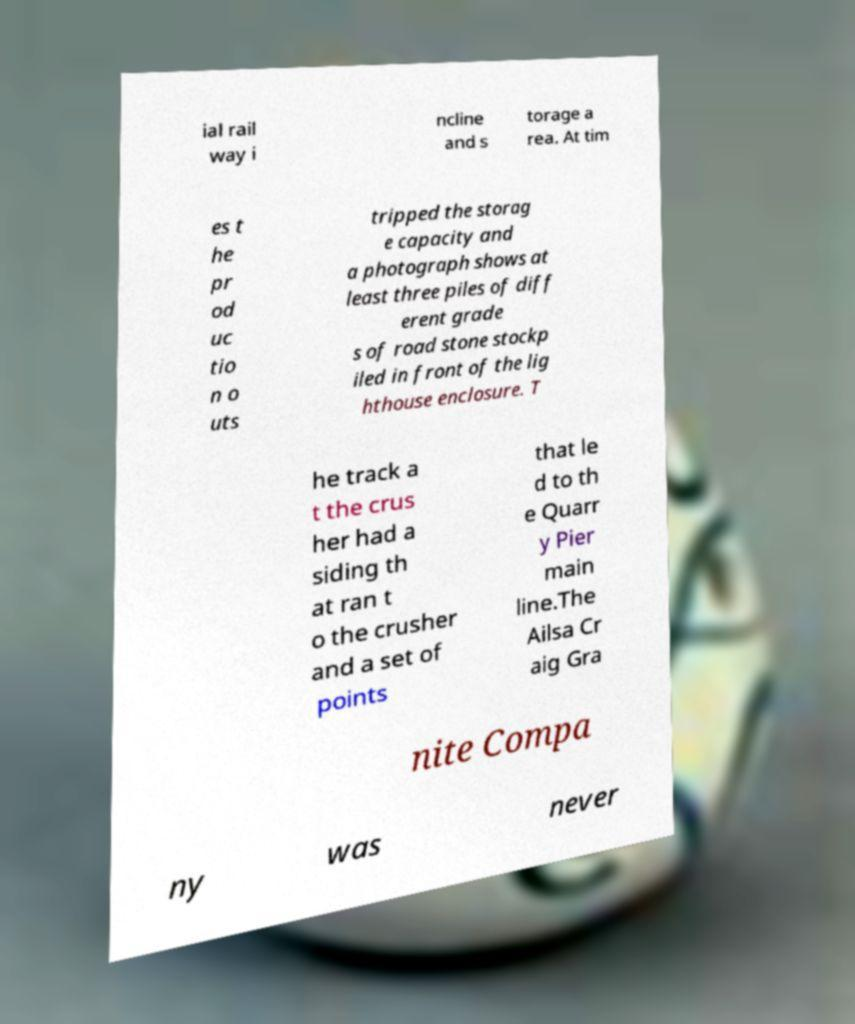Could you extract and type out the text from this image? ial rail way i ncline and s torage a rea. At tim es t he pr od uc tio n o uts tripped the storag e capacity and a photograph shows at least three piles of diff erent grade s of road stone stockp iled in front of the lig hthouse enclosure. T he track a t the crus her had a siding th at ran t o the crusher and a set of points that le d to th e Quarr y Pier main line.The Ailsa Cr aig Gra nite Compa ny was never 